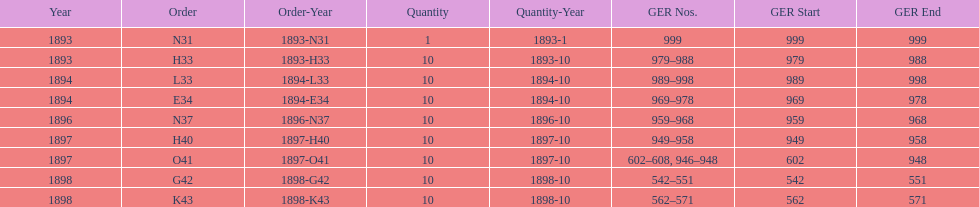What is the number of years with a quantity of 10? 5. 